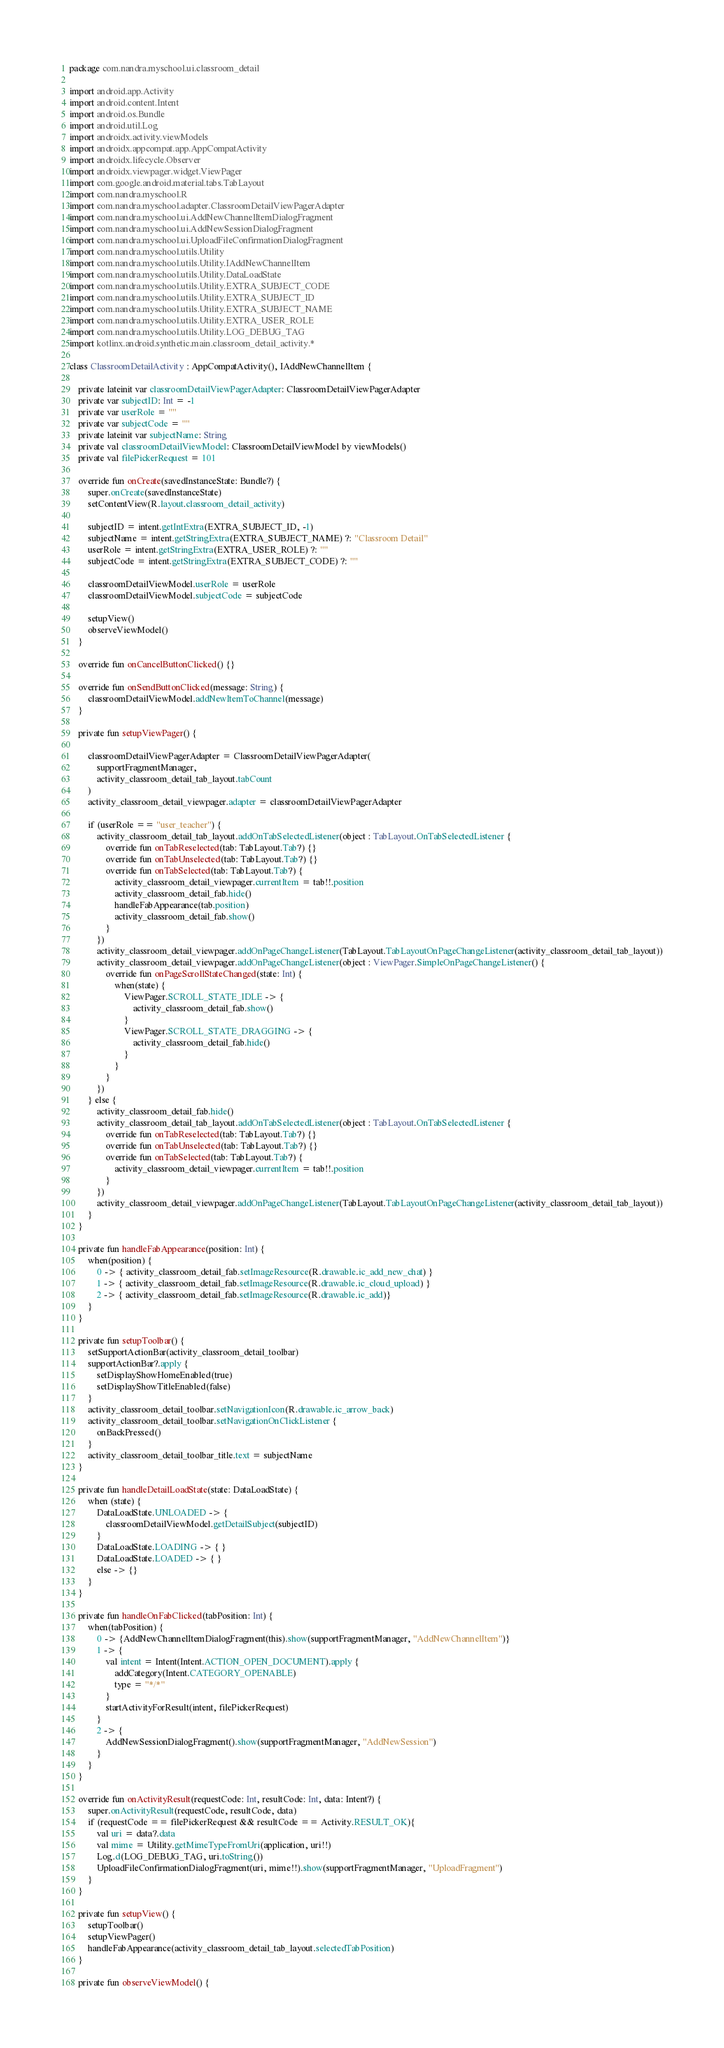<code> <loc_0><loc_0><loc_500><loc_500><_Kotlin_>package com.nandra.myschool.ui.classroom_detail

import android.app.Activity
import android.content.Intent
import android.os.Bundle
import android.util.Log
import androidx.activity.viewModels
import androidx.appcompat.app.AppCompatActivity
import androidx.lifecycle.Observer
import androidx.viewpager.widget.ViewPager
import com.google.android.material.tabs.TabLayout
import com.nandra.myschool.R
import com.nandra.myschool.adapter.ClassroomDetailViewPagerAdapter
import com.nandra.myschool.ui.AddNewChannelItemDialogFragment
import com.nandra.myschool.ui.AddNewSessionDialogFragment
import com.nandra.myschool.ui.UploadFileConfirmationDialogFragment
import com.nandra.myschool.utils.Utility
import com.nandra.myschool.utils.Utility.IAddNewChannelItem
import com.nandra.myschool.utils.Utility.DataLoadState
import com.nandra.myschool.utils.Utility.EXTRA_SUBJECT_CODE
import com.nandra.myschool.utils.Utility.EXTRA_SUBJECT_ID
import com.nandra.myschool.utils.Utility.EXTRA_SUBJECT_NAME
import com.nandra.myschool.utils.Utility.EXTRA_USER_ROLE
import com.nandra.myschool.utils.Utility.LOG_DEBUG_TAG
import kotlinx.android.synthetic.main.classroom_detail_activity.*

class ClassroomDetailActivity : AppCompatActivity(), IAddNewChannelItem {

    private lateinit var classroomDetailViewPagerAdapter: ClassroomDetailViewPagerAdapter
    private var subjectID: Int = -1
    private var userRole = ""
    private var subjectCode = ""
    private lateinit var subjectName: String
    private val classroomDetailViewModel: ClassroomDetailViewModel by viewModels()
    private val filePickerRequest = 101

    override fun onCreate(savedInstanceState: Bundle?) {
        super.onCreate(savedInstanceState)
        setContentView(R.layout.classroom_detail_activity)

        subjectID = intent.getIntExtra(EXTRA_SUBJECT_ID, -1)
        subjectName = intent.getStringExtra(EXTRA_SUBJECT_NAME) ?: "Classroom Detail"
        userRole = intent.getStringExtra(EXTRA_USER_ROLE) ?: ""
        subjectCode = intent.getStringExtra(EXTRA_SUBJECT_CODE) ?: ""

        classroomDetailViewModel.userRole = userRole
        classroomDetailViewModel.subjectCode = subjectCode

        setupView()
        observeViewModel()
    }

    override fun onCancelButtonClicked() {}

    override fun onSendButtonClicked(message: String) {
        classroomDetailViewModel.addNewItemToChannel(message)
    }

    private fun setupViewPager() {

        classroomDetailViewPagerAdapter = ClassroomDetailViewPagerAdapter(
            supportFragmentManager,
            activity_classroom_detail_tab_layout.tabCount
        )
        activity_classroom_detail_viewpager.adapter = classroomDetailViewPagerAdapter

        if (userRole == "user_teacher") {
            activity_classroom_detail_tab_layout.addOnTabSelectedListener(object : TabLayout.OnTabSelectedListener {
                override fun onTabReselected(tab: TabLayout.Tab?) {}
                override fun onTabUnselected(tab: TabLayout.Tab?) {}
                override fun onTabSelected(tab: TabLayout.Tab?) {
                    activity_classroom_detail_viewpager.currentItem = tab!!.position
                    activity_classroom_detail_fab.hide()
                    handleFabAppearance(tab.position)
                    activity_classroom_detail_fab.show()
                }
            })
            activity_classroom_detail_viewpager.addOnPageChangeListener(TabLayout.TabLayoutOnPageChangeListener(activity_classroom_detail_tab_layout))
            activity_classroom_detail_viewpager.addOnPageChangeListener(object : ViewPager.SimpleOnPageChangeListener() {
                override fun onPageScrollStateChanged(state: Int) {
                    when(state) {
                        ViewPager.SCROLL_STATE_IDLE -> {
                            activity_classroom_detail_fab.show()
                        }
                        ViewPager.SCROLL_STATE_DRAGGING -> {
                            activity_classroom_detail_fab.hide()
                        }
                    }
                }
            })
        } else {
            activity_classroom_detail_fab.hide()
            activity_classroom_detail_tab_layout.addOnTabSelectedListener(object : TabLayout.OnTabSelectedListener {
                override fun onTabReselected(tab: TabLayout.Tab?) {}
                override fun onTabUnselected(tab: TabLayout.Tab?) {}
                override fun onTabSelected(tab: TabLayout.Tab?) {
                    activity_classroom_detail_viewpager.currentItem = tab!!.position
                }
            })
            activity_classroom_detail_viewpager.addOnPageChangeListener(TabLayout.TabLayoutOnPageChangeListener(activity_classroom_detail_tab_layout))
        }
    }

    private fun handleFabAppearance(position: Int) {
        when(position) {
            0 -> { activity_classroom_detail_fab.setImageResource(R.drawable.ic_add_new_chat) }
            1 -> { activity_classroom_detail_fab.setImageResource(R.drawable.ic_cloud_upload) }
            2 -> { activity_classroom_detail_fab.setImageResource(R.drawable.ic_add)}
        }
    }

    private fun setupToolbar() {
        setSupportActionBar(activity_classroom_detail_toolbar)
        supportActionBar?.apply {
            setDisplayShowHomeEnabled(true)
            setDisplayShowTitleEnabled(false)
        }
        activity_classroom_detail_toolbar.setNavigationIcon(R.drawable.ic_arrow_back)
        activity_classroom_detail_toolbar.setNavigationOnClickListener {
            onBackPressed()
        }
        activity_classroom_detail_toolbar_title.text = subjectName
    }

    private fun handleDetailLoadState(state: DataLoadState) {
        when (state) {
            DataLoadState.UNLOADED -> {
                classroomDetailViewModel.getDetailSubject(subjectID)
            }
            DataLoadState.LOADING -> { }
            DataLoadState.LOADED -> { }
            else -> {}
        }
    }

    private fun handleOnFabClicked(tabPosition: Int) {
        when(tabPosition) {
            0 -> {AddNewChannelItemDialogFragment(this).show(supportFragmentManager, "AddNewChannelItem")}
            1 -> {
                val intent = Intent(Intent.ACTION_OPEN_DOCUMENT).apply {
                    addCategory(Intent.CATEGORY_OPENABLE)
                    type = "*/*"
                }
                startActivityForResult(intent, filePickerRequest)
            }
            2 -> {
                AddNewSessionDialogFragment().show(supportFragmentManager, "AddNewSession")
            }
        }
    }

    override fun onActivityResult(requestCode: Int, resultCode: Int, data: Intent?) {
        super.onActivityResult(requestCode, resultCode, data)
        if (requestCode == filePickerRequest && resultCode == Activity.RESULT_OK){
            val uri = data?.data
            val mime = Utility.getMimeTypeFromUri(application, uri!!)
            Log.d(LOG_DEBUG_TAG, uri.toString())
            UploadFileConfirmationDialogFragment(uri, mime!!).show(supportFragmentManager, "UploadFragment")
        }
    }

    private fun setupView() {
        setupToolbar()
        setupViewPager()
        handleFabAppearance(activity_classroom_detail_tab_layout.selectedTabPosition)
    }

    private fun observeViewModel() {</code> 